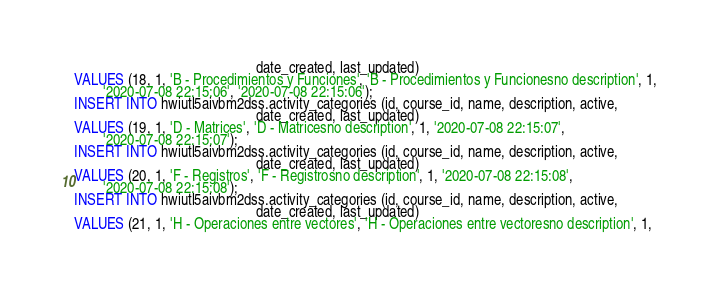<code> <loc_0><loc_0><loc_500><loc_500><_SQL_>                                                  date_created, last_updated)
VALUES (18, 1, 'B - Procedimientos y Funciones', 'B - Procedimientos y Funcionesno description', 1,
        '2020-07-08 22:15:06', '2020-07-08 22:15:06');
INSERT INTO hwiutl5aivbm2dss.activity_categories (id, course_id, name, description, active,
                                                  date_created, last_updated)
VALUES (19, 1, 'D - Matrices', 'D - Matricesno description', 1, '2020-07-08 22:15:07',
        '2020-07-08 22:15:07');
INSERT INTO hwiutl5aivbm2dss.activity_categories (id, course_id, name, description, active,
                                                  date_created, last_updated)
VALUES (20, 1, 'F - Registros', 'F - Registrosno description', 1, '2020-07-08 22:15:08',
        '2020-07-08 22:15:08');
INSERT INTO hwiutl5aivbm2dss.activity_categories (id, course_id, name, description, active,
                                                  date_created, last_updated)
VALUES (21, 1, 'H - Operaciones entre vectores', 'H - Operaciones entre vectoresno description', 1,</code> 